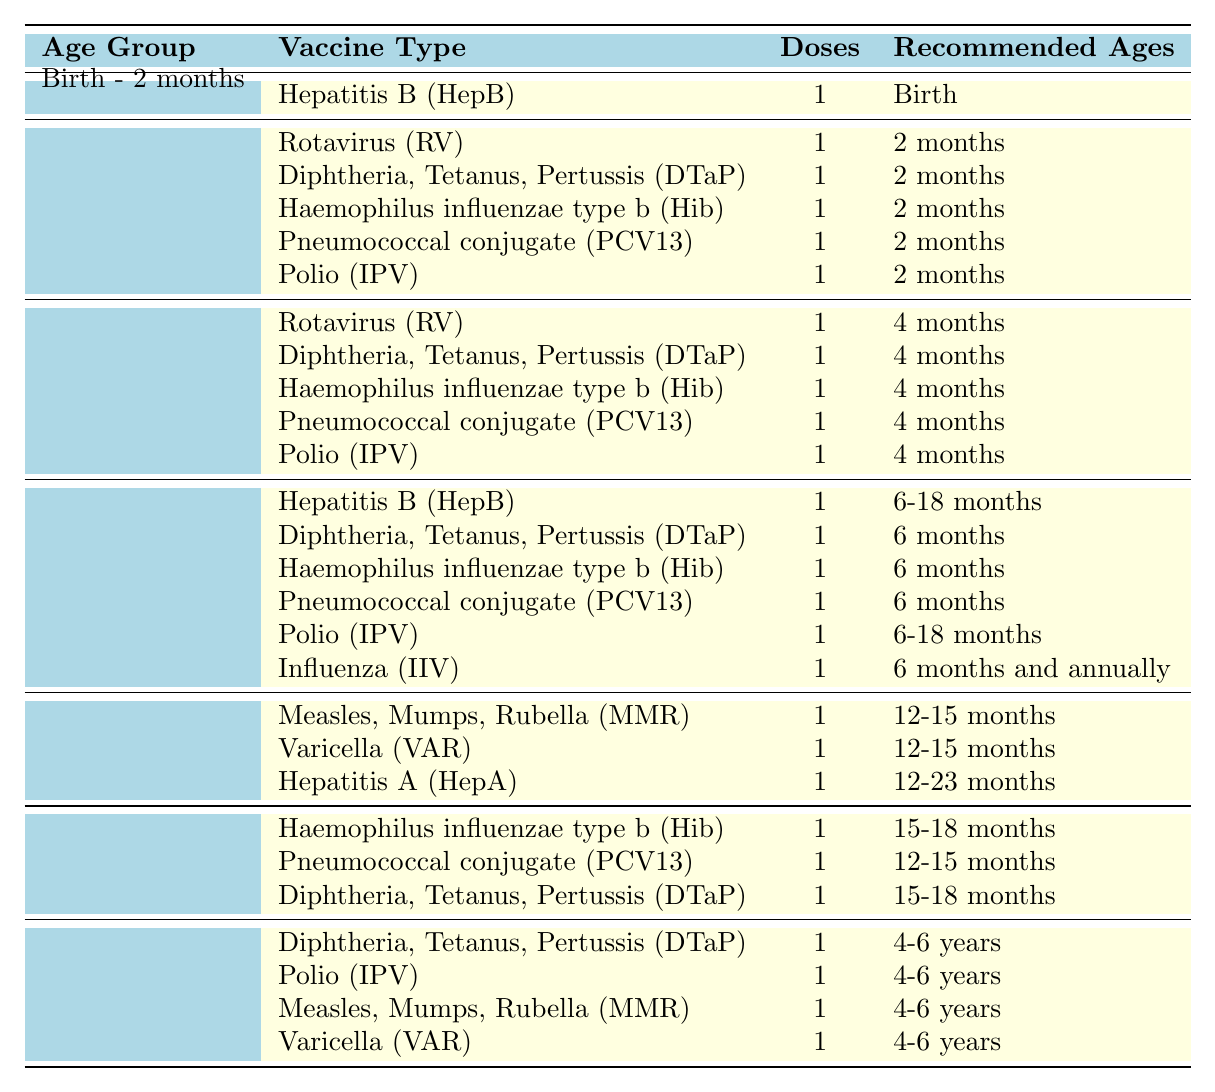What vaccines are recommended for infants aged 2 to 4 months? The table shows that infants in the 2 to 4 months age group receive five vaccines: Rotavirus (RV), Diphtheria, Tetanus, Pertussis (DTaP), Haemophilus influenzae type b (Hib), Pneumococcal conjugate (PCV13), and Polio (IPV).
Answer: Rotavirus, DTaP, Hib, PCV13, IPV How many doses of the Influenza vaccine are recommended for children? According to the table, children are recommended to receive 1 dose of the Influenza vaccine (IIV) starting at 6 months of age and annually thereafter.
Answer: 1 dose Is the Hepatitis A vaccine recommended for children before they turn 12 months? The table indicates that the Hepatitis A (HepA) vaccine is recommended for children between 12 to 23 months, which means it is not recommended before they turn 12 months.
Answer: No How many vaccines should a child receive by the age of 12 months? Looking at the vaccine schedule for each age group up to 12 months, we can sum the doses: 1 (Birth - 2 months) + 5 (2 - 4 months) + 5 (4 - 6 months) + 6 (6 - 12 months) = 17 doses total.
Answer: 17 doses Are there any vaccines that are given at both 6 months and 15-18 months? The DTaP vaccine is administered at both 6 months and 15-18 months, according to the vaccine schedule for those age groups.
Answer: Yes What is the total number of different vaccine types administered between 2 - 4 months and 4 - 6 months? The 2 - 4 months age group has 5 vaccines, and the 4 - 6 months age group has the same number of 5 vaccines. Thus, the total is 5 + 5 = 10 different vaccines.
Answer: 10 vaccines Which vaccine is only given once between the ages of 12-23 months? The Hepatitis A (HepA) vaccine is administered once during the ages of 12 to 23 months, as noted in the table.
Answer: Hepatitis A (HepA) How often do children need to get the Polio vaccine according to the table? The table lists Polio (IPV) being given at 2 months, 4 months, 6 months, and again at 15-18 months, indicating a total of 4 doses in their early vaccination schedule.
Answer: 4 doses What is the last vaccine age-group listed in the vaccination schedule? The last age group in the vaccination schedule is 4 - 6 years, which appears at the bottom of the table.
Answer: 4 - 6 years Which vaccines require repeated doses within the first 12 months? The vaccines requiring repeated doses within the first 12 months include DTaP, Hib, PCV13, and IPV, as each is given at multiple points within the specified age groups.
Answer: DTaP, Hib, PCV13, IPV 